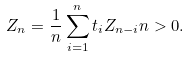Convert formula to latex. <formula><loc_0><loc_0><loc_500><loc_500>Z _ { n } = \frac { 1 } { n } \sum _ { i = 1 } ^ { n } t _ { i } Z _ { n - i } n > 0 .</formula> 